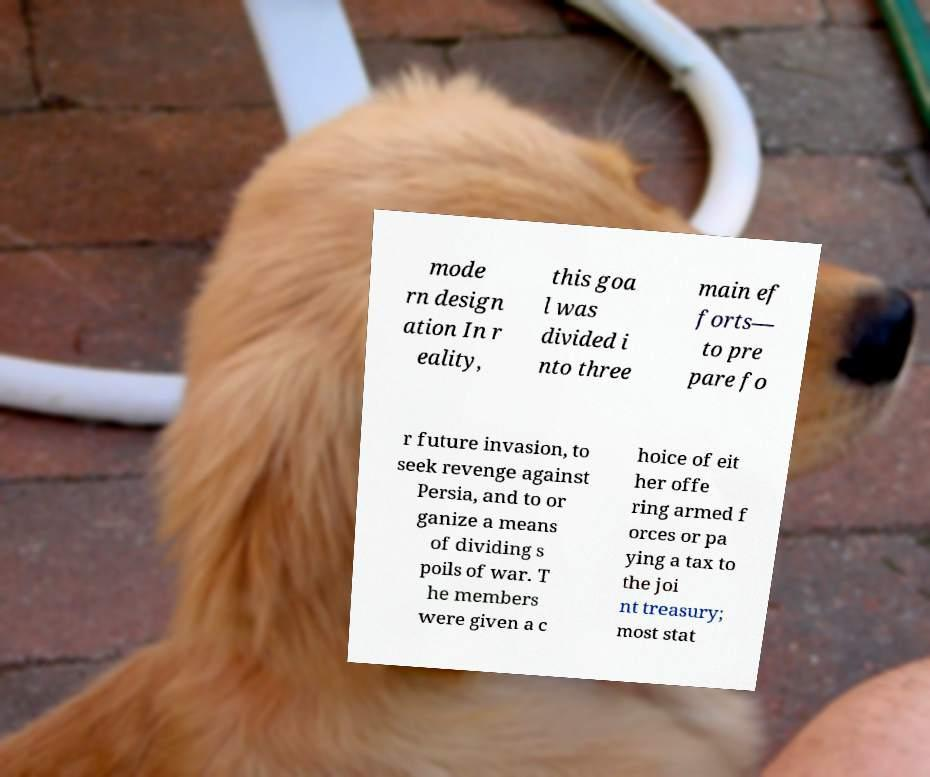I need the written content from this picture converted into text. Can you do that? mode rn design ation In r eality, this goa l was divided i nto three main ef forts— to pre pare fo r future invasion, to seek revenge against Persia, and to or ganize a means of dividing s poils of war. T he members were given a c hoice of eit her offe ring armed f orces or pa ying a tax to the joi nt treasury; most stat 